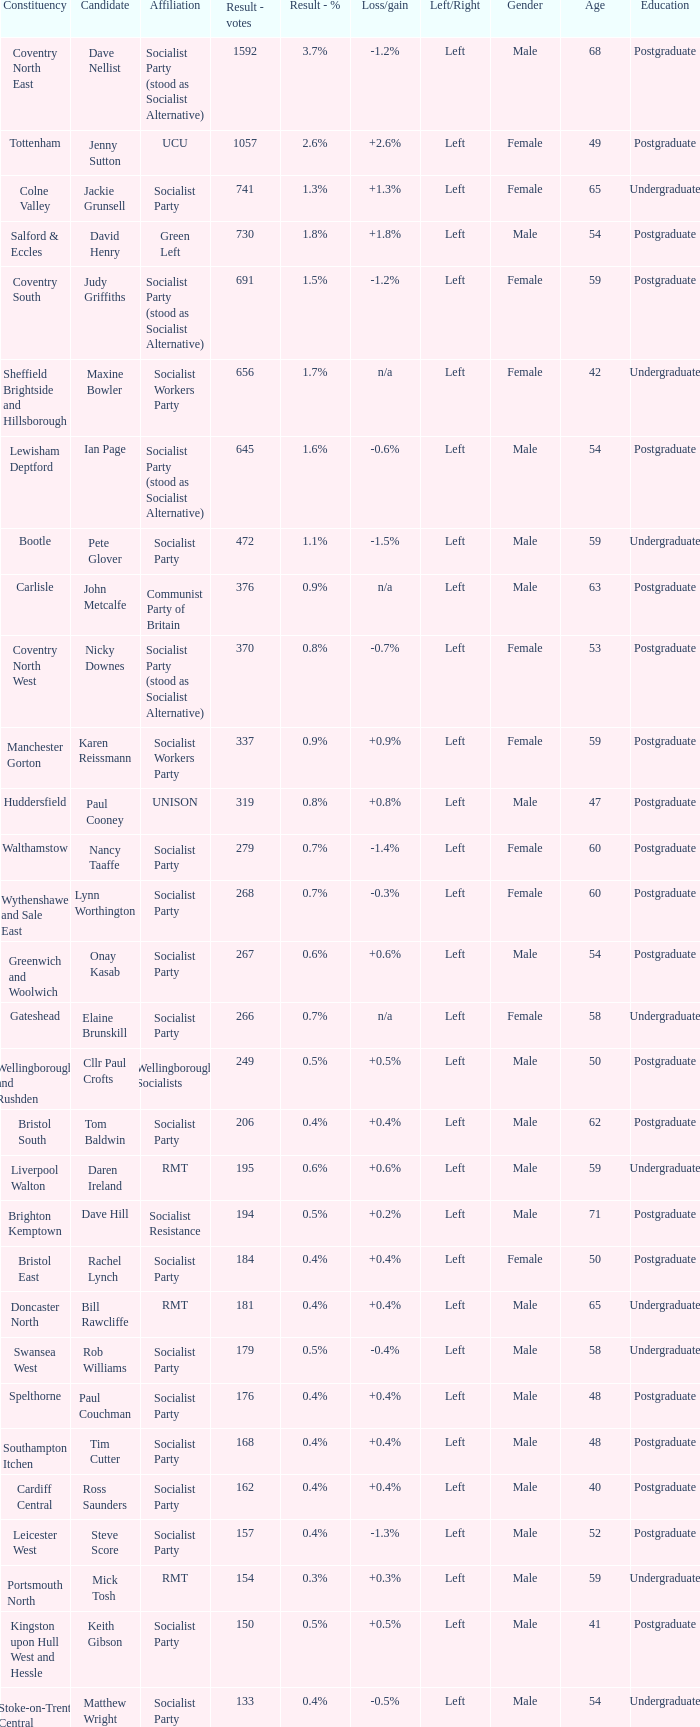What is the largest vote result for the Huddersfield constituency? 319.0. 